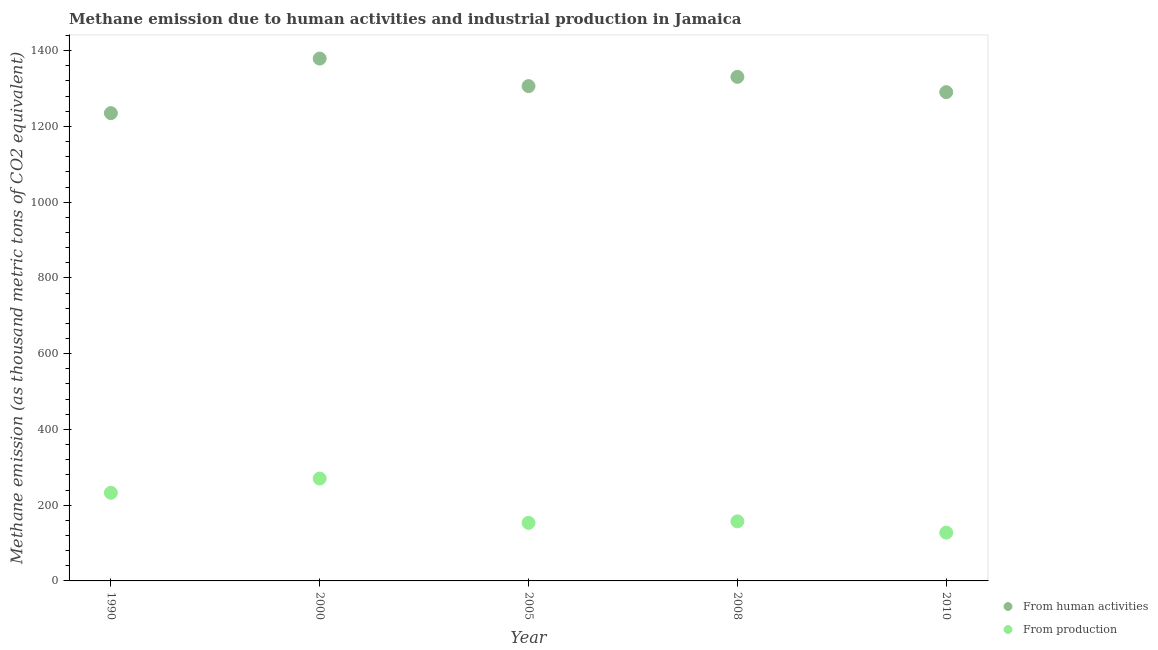How many different coloured dotlines are there?
Provide a short and direct response. 2. Is the number of dotlines equal to the number of legend labels?
Offer a terse response. Yes. What is the amount of emissions from human activities in 2010?
Your answer should be compact. 1290.6. Across all years, what is the maximum amount of emissions from human activities?
Your answer should be compact. 1379.2. Across all years, what is the minimum amount of emissions from human activities?
Provide a succinct answer. 1235.1. In which year was the amount of emissions from human activities maximum?
Keep it short and to the point. 2000. What is the total amount of emissions generated from industries in the graph?
Provide a succinct answer. 941.2. What is the difference between the amount of emissions generated from industries in 1990 and that in 2010?
Ensure brevity in your answer.  105.2. What is the difference between the amount of emissions generated from industries in 1990 and the amount of emissions from human activities in 2000?
Give a very brief answer. -1146.5. What is the average amount of emissions generated from industries per year?
Your answer should be very brief. 188.24. In the year 1990, what is the difference between the amount of emissions generated from industries and amount of emissions from human activities?
Ensure brevity in your answer.  -1002.4. In how many years, is the amount of emissions generated from industries greater than 1200 thousand metric tons?
Offer a terse response. 0. What is the ratio of the amount of emissions generated from industries in 2005 to that in 2010?
Give a very brief answer. 1.2. What is the difference between the highest and the second highest amount of emissions generated from industries?
Your answer should be very brief. 37.7. What is the difference between the highest and the lowest amount of emissions from human activities?
Offer a very short reply. 144.1. Is the sum of the amount of emissions generated from industries in 2005 and 2008 greater than the maximum amount of emissions from human activities across all years?
Provide a succinct answer. No. Does the amount of emissions from human activities monotonically increase over the years?
Offer a very short reply. No. Is the amount of emissions generated from industries strictly less than the amount of emissions from human activities over the years?
Your answer should be very brief. Yes. How many years are there in the graph?
Offer a very short reply. 5. Does the graph contain grids?
Your answer should be compact. No. How many legend labels are there?
Ensure brevity in your answer.  2. How are the legend labels stacked?
Provide a succinct answer. Vertical. What is the title of the graph?
Ensure brevity in your answer.  Methane emission due to human activities and industrial production in Jamaica. Does "Primary education" appear as one of the legend labels in the graph?
Offer a very short reply. No. What is the label or title of the X-axis?
Offer a very short reply. Year. What is the label or title of the Y-axis?
Offer a terse response. Methane emission (as thousand metric tons of CO2 equivalent). What is the Methane emission (as thousand metric tons of CO2 equivalent) of From human activities in 1990?
Keep it short and to the point. 1235.1. What is the Methane emission (as thousand metric tons of CO2 equivalent) of From production in 1990?
Ensure brevity in your answer.  232.7. What is the Methane emission (as thousand metric tons of CO2 equivalent) of From human activities in 2000?
Your response must be concise. 1379.2. What is the Methane emission (as thousand metric tons of CO2 equivalent) of From production in 2000?
Provide a succinct answer. 270.4. What is the Methane emission (as thousand metric tons of CO2 equivalent) in From human activities in 2005?
Ensure brevity in your answer.  1306.5. What is the Methane emission (as thousand metric tons of CO2 equivalent) in From production in 2005?
Your response must be concise. 153.3. What is the Methane emission (as thousand metric tons of CO2 equivalent) in From human activities in 2008?
Provide a succinct answer. 1330.9. What is the Methane emission (as thousand metric tons of CO2 equivalent) of From production in 2008?
Ensure brevity in your answer.  157.3. What is the Methane emission (as thousand metric tons of CO2 equivalent) in From human activities in 2010?
Provide a succinct answer. 1290.6. What is the Methane emission (as thousand metric tons of CO2 equivalent) in From production in 2010?
Give a very brief answer. 127.5. Across all years, what is the maximum Methane emission (as thousand metric tons of CO2 equivalent) of From human activities?
Make the answer very short. 1379.2. Across all years, what is the maximum Methane emission (as thousand metric tons of CO2 equivalent) of From production?
Offer a terse response. 270.4. Across all years, what is the minimum Methane emission (as thousand metric tons of CO2 equivalent) in From human activities?
Keep it short and to the point. 1235.1. Across all years, what is the minimum Methane emission (as thousand metric tons of CO2 equivalent) in From production?
Make the answer very short. 127.5. What is the total Methane emission (as thousand metric tons of CO2 equivalent) in From human activities in the graph?
Provide a succinct answer. 6542.3. What is the total Methane emission (as thousand metric tons of CO2 equivalent) in From production in the graph?
Ensure brevity in your answer.  941.2. What is the difference between the Methane emission (as thousand metric tons of CO2 equivalent) in From human activities in 1990 and that in 2000?
Provide a succinct answer. -144.1. What is the difference between the Methane emission (as thousand metric tons of CO2 equivalent) of From production in 1990 and that in 2000?
Provide a short and direct response. -37.7. What is the difference between the Methane emission (as thousand metric tons of CO2 equivalent) in From human activities in 1990 and that in 2005?
Provide a succinct answer. -71.4. What is the difference between the Methane emission (as thousand metric tons of CO2 equivalent) in From production in 1990 and that in 2005?
Provide a succinct answer. 79.4. What is the difference between the Methane emission (as thousand metric tons of CO2 equivalent) of From human activities in 1990 and that in 2008?
Make the answer very short. -95.8. What is the difference between the Methane emission (as thousand metric tons of CO2 equivalent) in From production in 1990 and that in 2008?
Offer a very short reply. 75.4. What is the difference between the Methane emission (as thousand metric tons of CO2 equivalent) of From human activities in 1990 and that in 2010?
Your answer should be compact. -55.5. What is the difference between the Methane emission (as thousand metric tons of CO2 equivalent) of From production in 1990 and that in 2010?
Give a very brief answer. 105.2. What is the difference between the Methane emission (as thousand metric tons of CO2 equivalent) in From human activities in 2000 and that in 2005?
Ensure brevity in your answer.  72.7. What is the difference between the Methane emission (as thousand metric tons of CO2 equivalent) in From production in 2000 and that in 2005?
Ensure brevity in your answer.  117.1. What is the difference between the Methane emission (as thousand metric tons of CO2 equivalent) of From human activities in 2000 and that in 2008?
Offer a very short reply. 48.3. What is the difference between the Methane emission (as thousand metric tons of CO2 equivalent) of From production in 2000 and that in 2008?
Offer a very short reply. 113.1. What is the difference between the Methane emission (as thousand metric tons of CO2 equivalent) in From human activities in 2000 and that in 2010?
Offer a very short reply. 88.6. What is the difference between the Methane emission (as thousand metric tons of CO2 equivalent) in From production in 2000 and that in 2010?
Give a very brief answer. 142.9. What is the difference between the Methane emission (as thousand metric tons of CO2 equivalent) in From human activities in 2005 and that in 2008?
Ensure brevity in your answer.  -24.4. What is the difference between the Methane emission (as thousand metric tons of CO2 equivalent) of From production in 2005 and that in 2008?
Your answer should be very brief. -4. What is the difference between the Methane emission (as thousand metric tons of CO2 equivalent) of From human activities in 2005 and that in 2010?
Offer a very short reply. 15.9. What is the difference between the Methane emission (as thousand metric tons of CO2 equivalent) in From production in 2005 and that in 2010?
Offer a terse response. 25.8. What is the difference between the Methane emission (as thousand metric tons of CO2 equivalent) of From human activities in 2008 and that in 2010?
Your answer should be compact. 40.3. What is the difference between the Methane emission (as thousand metric tons of CO2 equivalent) in From production in 2008 and that in 2010?
Ensure brevity in your answer.  29.8. What is the difference between the Methane emission (as thousand metric tons of CO2 equivalent) in From human activities in 1990 and the Methane emission (as thousand metric tons of CO2 equivalent) in From production in 2000?
Offer a terse response. 964.7. What is the difference between the Methane emission (as thousand metric tons of CO2 equivalent) of From human activities in 1990 and the Methane emission (as thousand metric tons of CO2 equivalent) of From production in 2005?
Give a very brief answer. 1081.8. What is the difference between the Methane emission (as thousand metric tons of CO2 equivalent) in From human activities in 1990 and the Methane emission (as thousand metric tons of CO2 equivalent) in From production in 2008?
Your answer should be very brief. 1077.8. What is the difference between the Methane emission (as thousand metric tons of CO2 equivalent) of From human activities in 1990 and the Methane emission (as thousand metric tons of CO2 equivalent) of From production in 2010?
Provide a succinct answer. 1107.6. What is the difference between the Methane emission (as thousand metric tons of CO2 equivalent) in From human activities in 2000 and the Methane emission (as thousand metric tons of CO2 equivalent) in From production in 2005?
Make the answer very short. 1225.9. What is the difference between the Methane emission (as thousand metric tons of CO2 equivalent) of From human activities in 2000 and the Methane emission (as thousand metric tons of CO2 equivalent) of From production in 2008?
Your answer should be compact. 1221.9. What is the difference between the Methane emission (as thousand metric tons of CO2 equivalent) in From human activities in 2000 and the Methane emission (as thousand metric tons of CO2 equivalent) in From production in 2010?
Offer a very short reply. 1251.7. What is the difference between the Methane emission (as thousand metric tons of CO2 equivalent) in From human activities in 2005 and the Methane emission (as thousand metric tons of CO2 equivalent) in From production in 2008?
Provide a short and direct response. 1149.2. What is the difference between the Methane emission (as thousand metric tons of CO2 equivalent) in From human activities in 2005 and the Methane emission (as thousand metric tons of CO2 equivalent) in From production in 2010?
Give a very brief answer. 1179. What is the difference between the Methane emission (as thousand metric tons of CO2 equivalent) in From human activities in 2008 and the Methane emission (as thousand metric tons of CO2 equivalent) in From production in 2010?
Offer a terse response. 1203.4. What is the average Methane emission (as thousand metric tons of CO2 equivalent) of From human activities per year?
Offer a very short reply. 1308.46. What is the average Methane emission (as thousand metric tons of CO2 equivalent) of From production per year?
Offer a terse response. 188.24. In the year 1990, what is the difference between the Methane emission (as thousand metric tons of CO2 equivalent) in From human activities and Methane emission (as thousand metric tons of CO2 equivalent) in From production?
Your answer should be compact. 1002.4. In the year 2000, what is the difference between the Methane emission (as thousand metric tons of CO2 equivalent) of From human activities and Methane emission (as thousand metric tons of CO2 equivalent) of From production?
Your response must be concise. 1108.8. In the year 2005, what is the difference between the Methane emission (as thousand metric tons of CO2 equivalent) of From human activities and Methane emission (as thousand metric tons of CO2 equivalent) of From production?
Provide a succinct answer. 1153.2. In the year 2008, what is the difference between the Methane emission (as thousand metric tons of CO2 equivalent) of From human activities and Methane emission (as thousand metric tons of CO2 equivalent) of From production?
Offer a very short reply. 1173.6. In the year 2010, what is the difference between the Methane emission (as thousand metric tons of CO2 equivalent) in From human activities and Methane emission (as thousand metric tons of CO2 equivalent) in From production?
Your response must be concise. 1163.1. What is the ratio of the Methane emission (as thousand metric tons of CO2 equivalent) in From human activities in 1990 to that in 2000?
Your response must be concise. 0.9. What is the ratio of the Methane emission (as thousand metric tons of CO2 equivalent) of From production in 1990 to that in 2000?
Give a very brief answer. 0.86. What is the ratio of the Methane emission (as thousand metric tons of CO2 equivalent) in From human activities in 1990 to that in 2005?
Your answer should be very brief. 0.95. What is the ratio of the Methane emission (as thousand metric tons of CO2 equivalent) of From production in 1990 to that in 2005?
Make the answer very short. 1.52. What is the ratio of the Methane emission (as thousand metric tons of CO2 equivalent) of From human activities in 1990 to that in 2008?
Provide a succinct answer. 0.93. What is the ratio of the Methane emission (as thousand metric tons of CO2 equivalent) in From production in 1990 to that in 2008?
Your answer should be very brief. 1.48. What is the ratio of the Methane emission (as thousand metric tons of CO2 equivalent) of From human activities in 1990 to that in 2010?
Keep it short and to the point. 0.96. What is the ratio of the Methane emission (as thousand metric tons of CO2 equivalent) in From production in 1990 to that in 2010?
Provide a succinct answer. 1.83. What is the ratio of the Methane emission (as thousand metric tons of CO2 equivalent) in From human activities in 2000 to that in 2005?
Keep it short and to the point. 1.06. What is the ratio of the Methane emission (as thousand metric tons of CO2 equivalent) of From production in 2000 to that in 2005?
Your answer should be compact. 1.76. What is the ratio of the Methane emission (as thousand metric tons of CO2 equivalent) in From human activities in 2000 to that in 2008?
Keep it short and to the point. 1.04. What is the ratio of the Methane emission (as thousand metric tons of CO2 equivalent) of From production in 2000 to that in 2008?
Keep it short and to the point. 1.72. What is the ratio of the Methane emission (as thousand metric tons of CO2 equivalent) of From human activities in 2000 to that in 2010?
Ensure brevity in your answer.  1.07. What is the ratio of the Methane emission (as thousand metric tons of CO2 equivalent) in From production in 2000 to that in 2010?
Ensure brevity in your answer.  2.12. What is the ratio of the Methane emission (as thousand metric tons of CO2 equivalent) of From human activities in 2005 to that in 2008?
Offer a very short reply. 0.98. What is the ratio of the Methane emission (as thousand metric tons of CO2 equivalent) in From production in 2005 to that in 2008?
Your answer should be very brief. 0.97. What is the ratio of the Methane emission (as thousand metric tons of CO2 equivalent) in From human activities in 2005 to that in 2010?
Your answer should be compact. 1.01. What is the ratio of the Methane emission (as thousand metric tons of CO2 equivalent) in From production in 2005 to that in 2010?
Offer a terse response. 1.2. What is the ratio of the Methane emission (as thousand metric tons of CO2 equivalent) in From human activities in 2008 to that in 2010?
Your answer should be compact. 1.03. What is the ratio of the Methane emission (as thousand metric tons of CO2 equivalent) of From production in 2008 to that in 2010?
Your answer should be very brief. 1.23. What is the difference between the highest and the second highest Methane emission (as thousand metric tons of CO2 equivalent) of From human activities?
Make the answer very short. 48.3. What is the difference between the highest and the second highest Methane emission (as thousand metric tons of CO2 equivalent) in From production?
Ensure brevity in your answer.  37.7. What is the difference between the highest and the lowest Methane emission (as thousand metric tons of CO2 equivalent) of From human activities?
Offer a terse response. 144.1. What is the difference between the highest and the lowest Methane emission (as thousand metric tons of CO2 equivalent) of From production?
Offer a terse response. 142.9. 